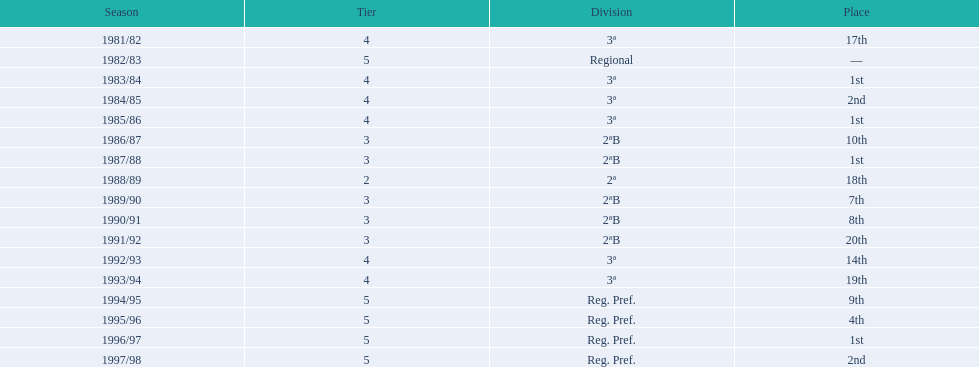What is the least ranking the team has attained? 20th. In what year did they end up in 20th place? 1991/92. 